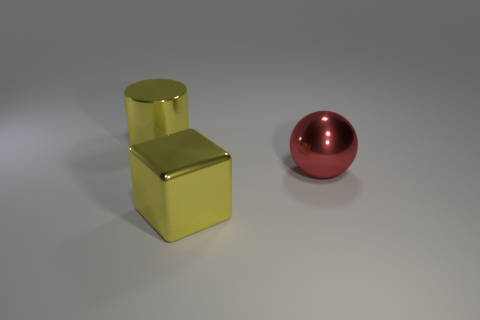What is the size of the red sphere that is made of the same material as the big yellow cube?
Your response must be concise. Large. Is the material of the yellow thing that is behind the red shiny object the same as the large yellow thing that is to the right of the yellow cylinder?
Your answer should be compact. Yes. How many blocks are either big things or big yellow metal objects?
Offer a very short reply. 1. There is a big yellow object in front of the thing that is left of the large yellow cube; how many large things are on the right side of it?
Your response must be concise. 1. What is the color of the large metallic thing in front of the big red shiny thing?
Offer a very short reply. Yellow. Do the block and the yellow thing that is behind the ball have the same material?
Ensure brevity in your answer.  Yes. What material is the ball?
Offer a very short reply. Metal. What shape is the big yellow object that is made of the same material as the yellow cylinder?
Your answer should be compact. Cube. How many other things are the same shape as the red thing?
Offer a terse response. 0. How many yellow things are on the left side of the large red metal thing?
Your response must be concise. 2. 